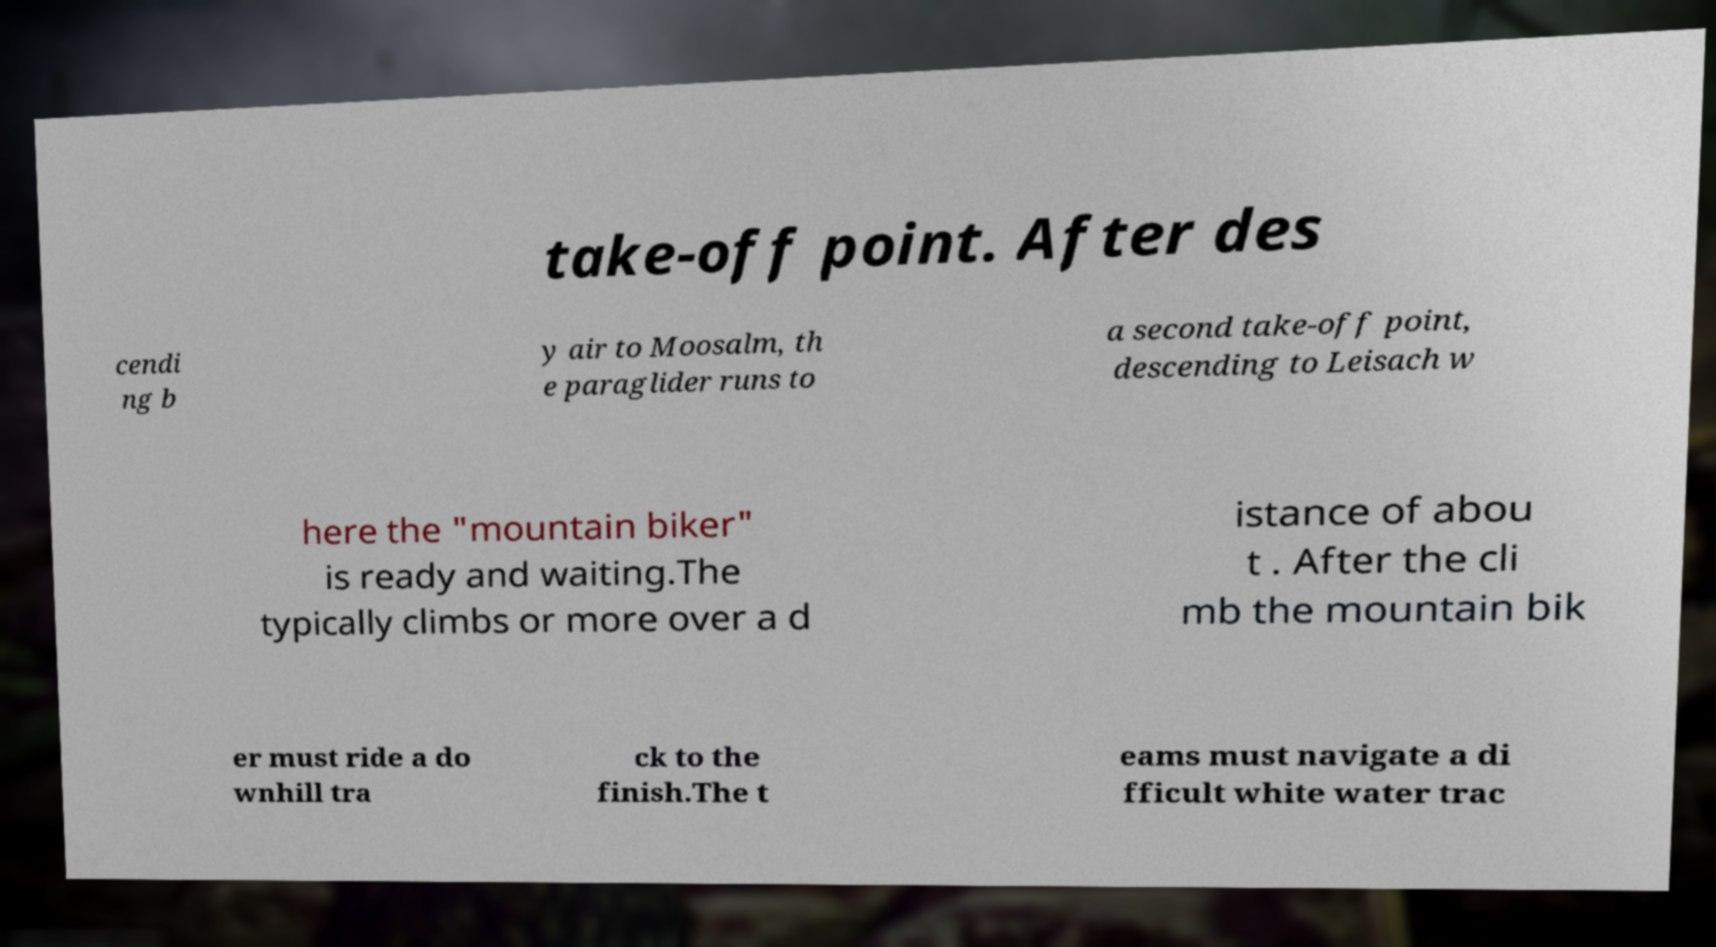Please identify and transcribe the text found in this image. take-off point. After des cendi ng b y air to Moosalm, th e paraglider runs to a second take-off point, descending to Leisach w here the "mountain biker" is ready and waiting.The typically climbs or more over a d istance of abou t . After the cli mb the mountain bik er must ride a do wnhill tra ck to the finish.The t eams must navigate a di fficult white water trac 